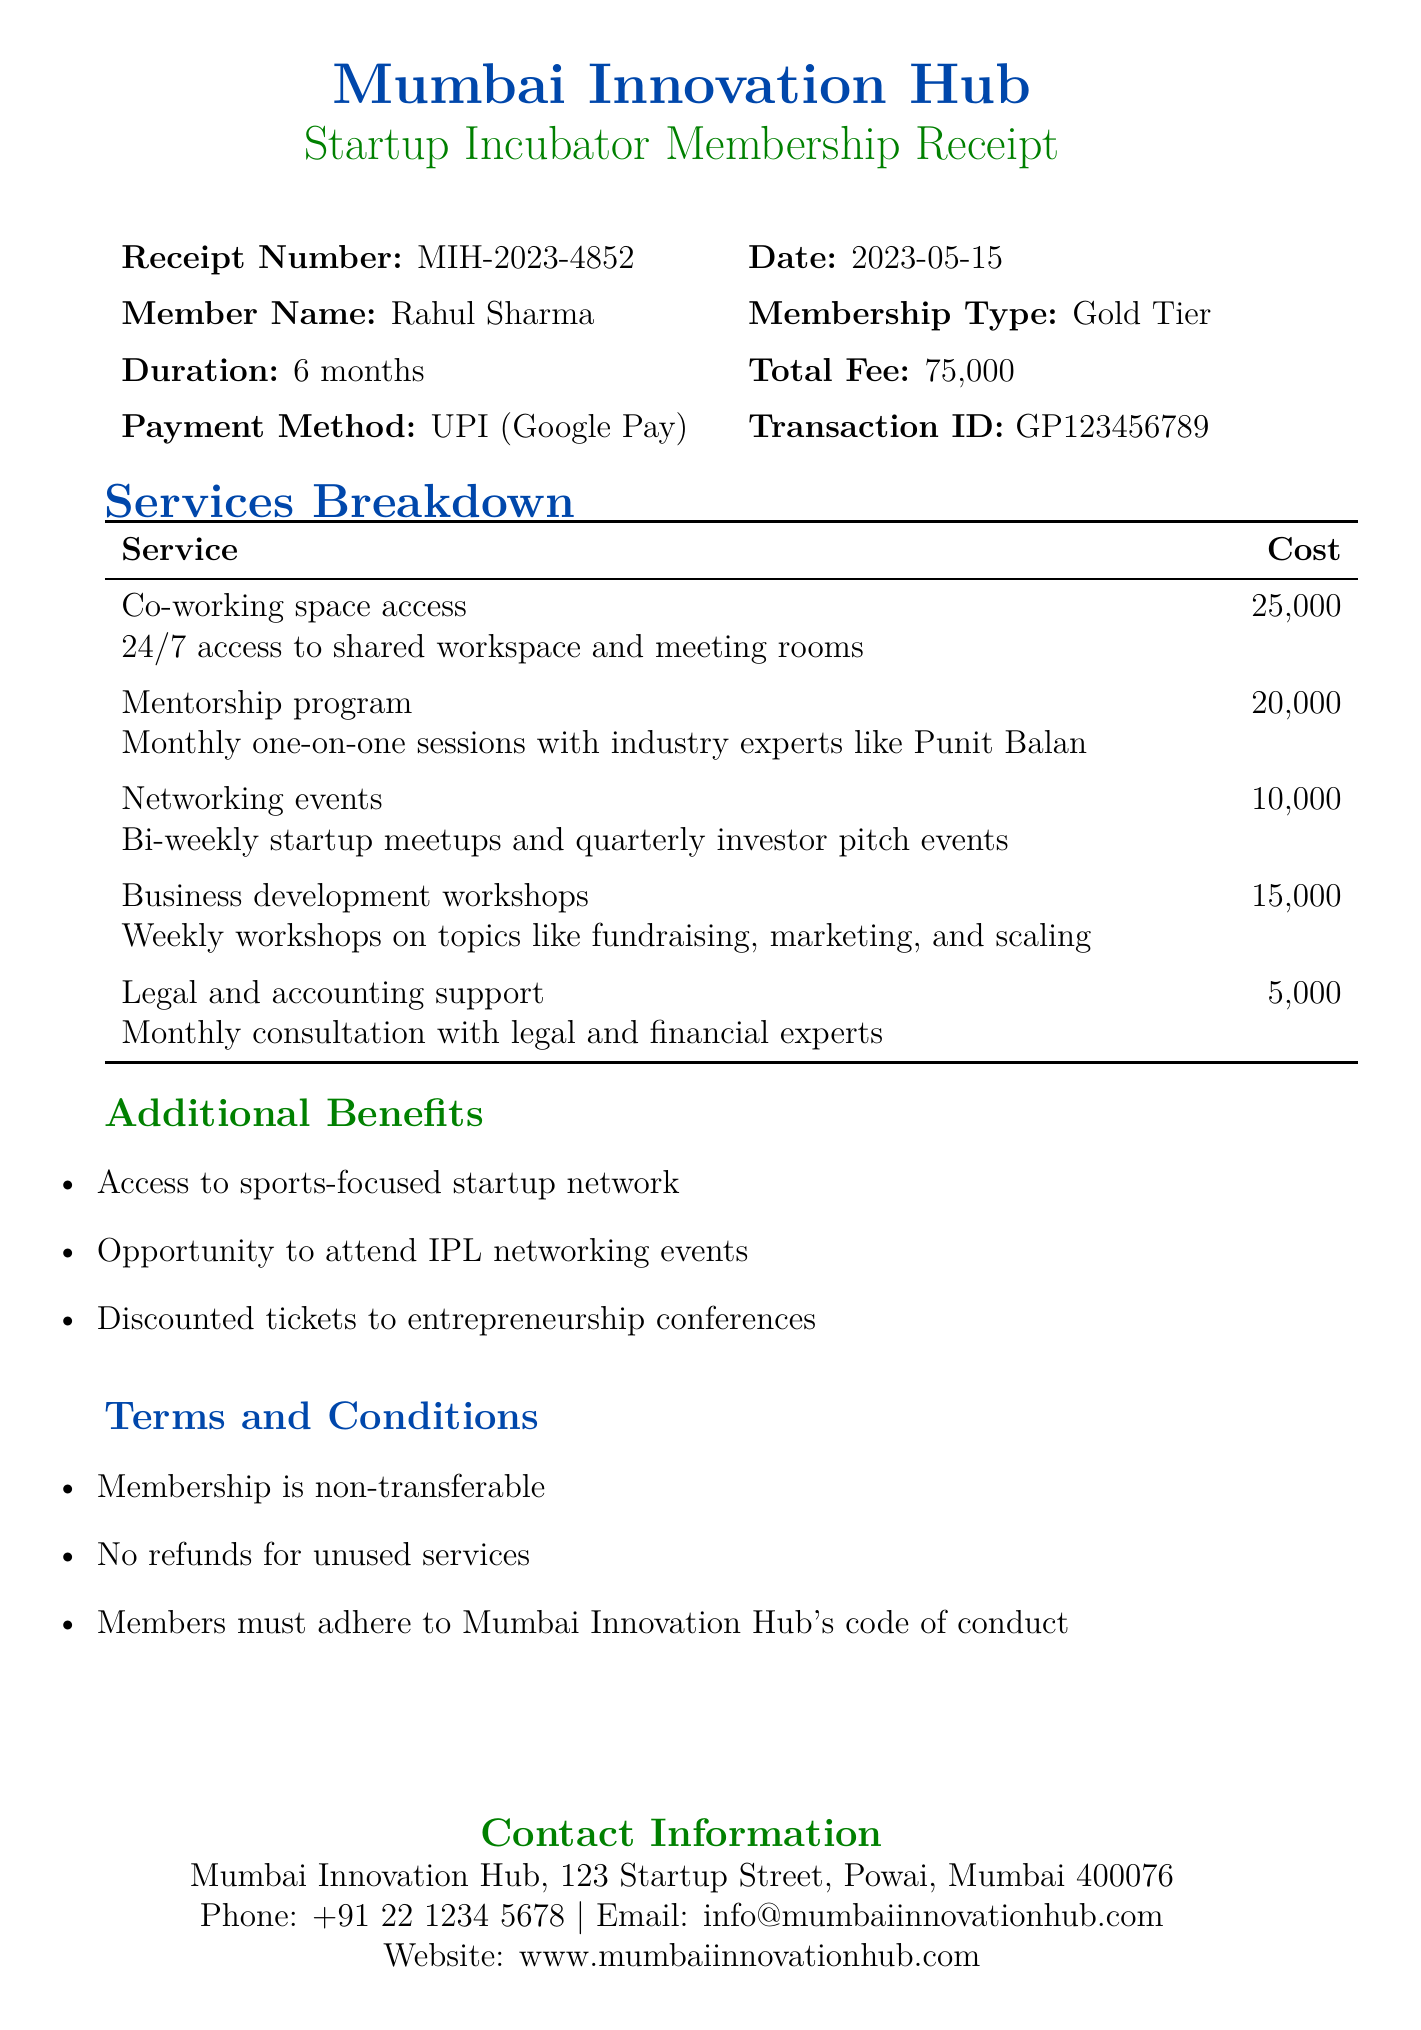What is the receipt number? The receipt number is a unique identifier for this document.
Answer: MIH-2023-4852 What is the total fee for the membership? The total fee represents the cost of the membership type selected.
Answer: ₹75,000 Who is the member? The member's name indicates who purchased the membership.
Answer: Rahul Sharma What type of membership is this? The membership type specifies the level of access and services included.
Answer: Gold Tier How long is the membership duration? The duration indicates the length of time the membership is valid for.
Answer: 6 months What is included in the legal support service? This service description summarizes what legal support members receive.
Answer: Monthly consultation with legal and financial experts How much does the mentorship program cost? The cost of this service is part of the overall membership fee breakdown.
Answer: ₹20,000 What additional benefit is focused on sports? This benefit highlights a specific networking opportunity for members.
Answer: Access to sports-focused startup network What is a term mentioned for the membership? This is a specific rule or guideline governing membership usage.
Answer: Membership is non-transferable 